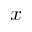Convert formula to latex. <formula><loc_0><loc_0><loc_500><loc_500>x</formula> 